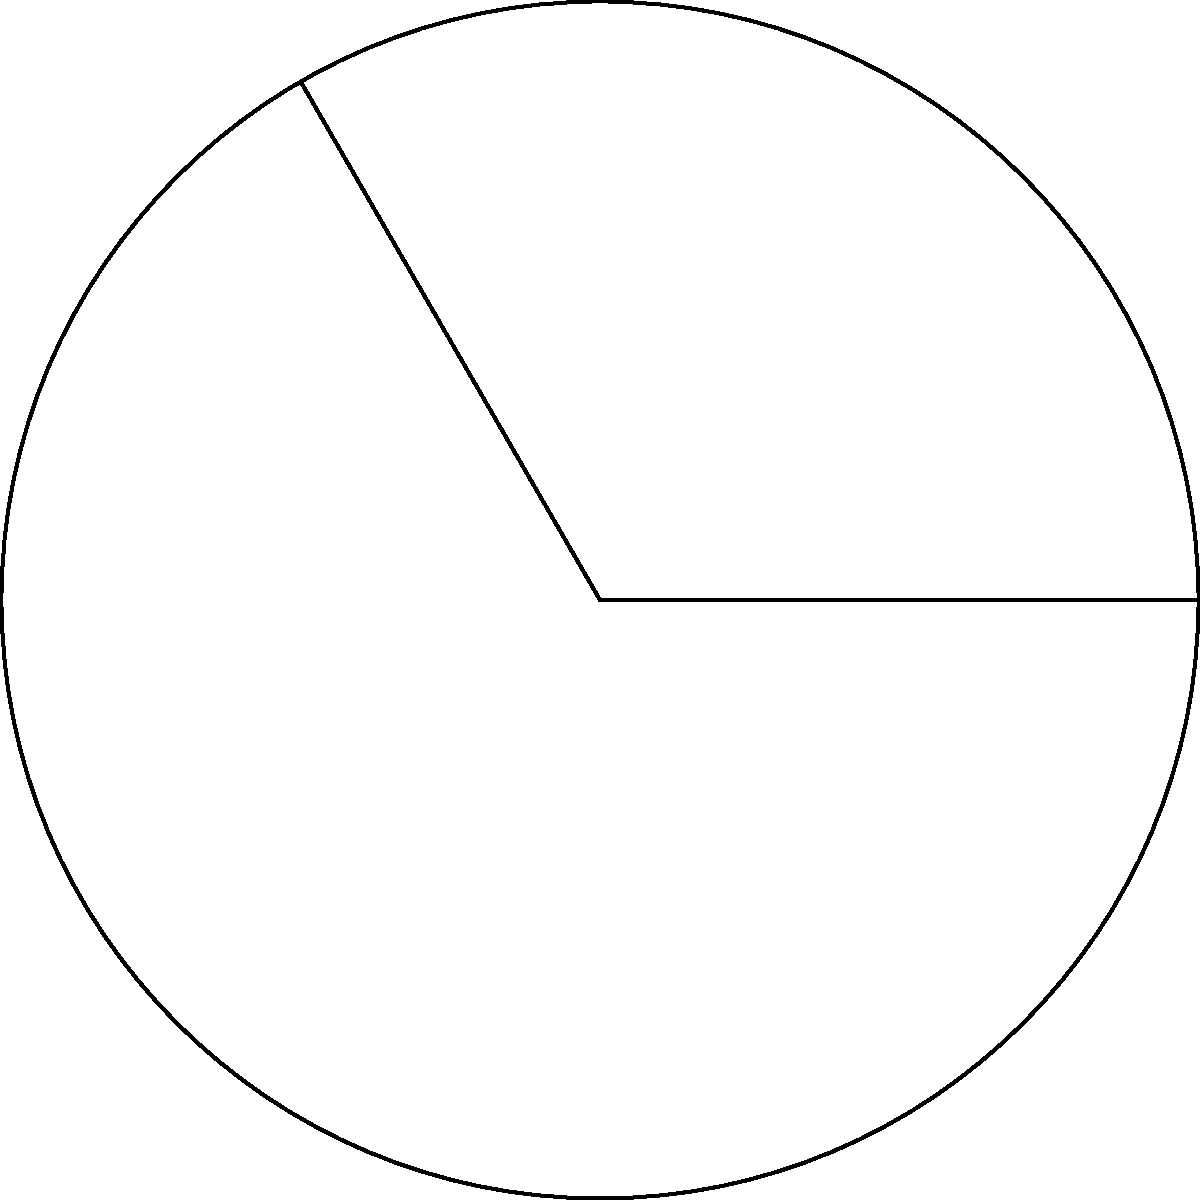As a managing partner evaluating a potential investment in a circular economy startup, you need to assess their market penetration strategy. The startup claims their product can cover a specific sector of the circular market. Given a circular market with a radius of 10 km and the startup's product covering a central angle of 120°, calculate the area of the market sector they can potentially serve. Round your answer to the nearest square kilometer. To solve this problem, we'll use the formula for the area of a circular sector:

$$A = \frac{1}{2}r^2\theta$$

Where:
$A$ = Area of the sector
$r$ = Radius of the circle
$\theta$ = Central angle in radians

Step 1: Convert the central angle from degrees to radians
$$\theta = 120° \times \frac{\pi}{180°} = \frac{2\pi}{3} \approx 2.0944\text{ radians}$$

Step 2: Apply the formula with $r = 10$ km and $\theta = \frac{2\pi}{3}$ radians
$$A = \frac{1}{2} \times 10^2 \times \frac{2\pi}{3}$$

Step 3: Calculate the result
$$A = \frac{100\pi}{3} \approx 104.72\text{ km}^2$$

Step 4: Round to the nearest square kilometer
$$A \approx 105\text{ km}^2$$

This result represents the potential market area the startup can serve with their product.
Answer: 105 km² 